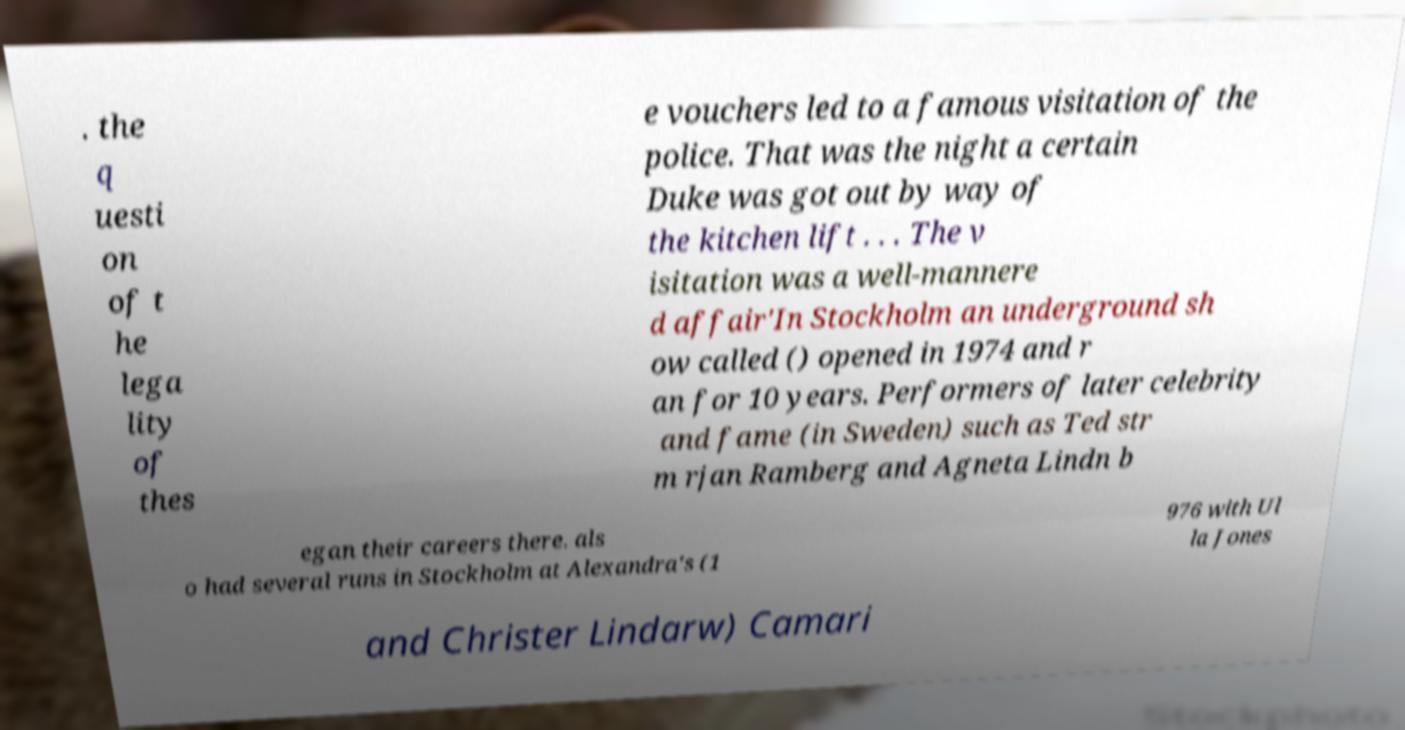Can you accurately transcribe the text from the provided image for me? . the q uesti on of t he lega lity of thes e vouchers led to a famous visitation of the police. That was the night a certain Duke was got out by way of the kitchen lift . . . The v isitation was a well-mannere d affair'In Stockholm an underground sh ow called () opened in 1974 and r an for 10 years. Performers of later celebrity and fame (in Sweden) such as Ted str m rjan Ramberg and Agneta Lindn b egan their careers there. als o had several runs in Stockholm at Alexandra's (1 976 with Ul la Jones and Christer Lindarw) Camari 